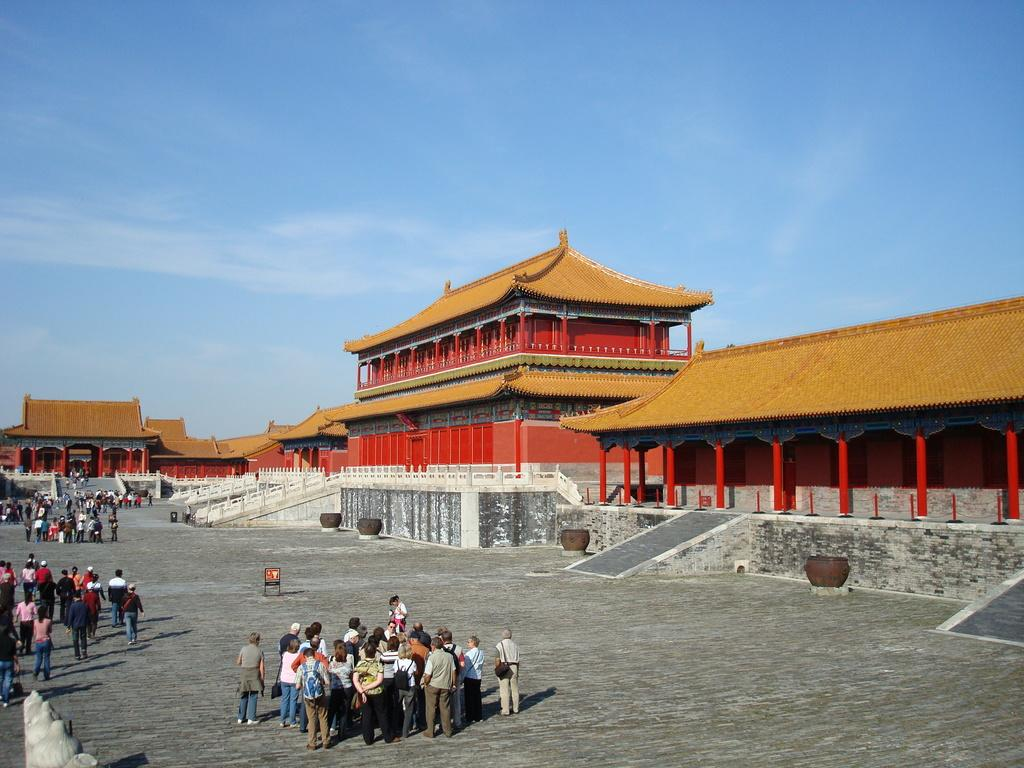Where was the image taken? The image was clicked outside. What is the main subject of the image? The image appears to show a temple. Can you describe the location of the temple in the image? The temple is in the middle of the image. What can be seen in the background of the image? The sky is visible at the top of the image. How many persons are visible in the image? There are multiple persons on the left side and bottom of the image. What type of science experiment can be seen being conducted by the ants in the image? There are no ants present in the image, and therefore no science experiment can be observed. What holiday is being celebrated in the image? There is no indication of a holiday being celebrated in the image. 